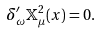<formula> <loc_0><loc_0><loc_500><loc_500>\delta _ { \omega } ^ { \prime } \mathbb { X } _ { \mu } ^ { 2 } ( x ) = 0 .</formula> 